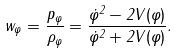Convert formula to latex. <formula><loc_0><loc_0><loc_500><loc_500>w _ { \varphi } = \frac { p _ { \varphi } } { \rho _ { \varphi } } = \frac { \dot { \varphi } ^ { 2 } - 2 V ( \varphi ) } { \dot { \varphi } ^ { 2 } + 2 V ( \varphi ) } .</formula> 